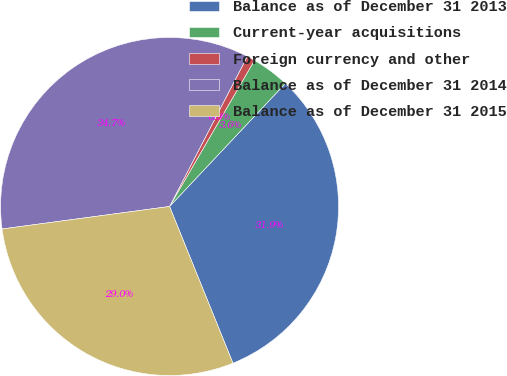Convert chart. <chart><loc_0><loc_0><loc_500><loc_500><pie_chart><fcel>Balance as of December 31 2013<fcel>Current-year acquisitions<fcel>Foreign currency and other<fcel>Balance as of December 31 2014<fcel>Balance as of December 31 2015<nl><fcel>31.86%<fcel>3.64%<fcel>0.77%<fcel>34.73%<fcel>28.99%<nl></chart> 